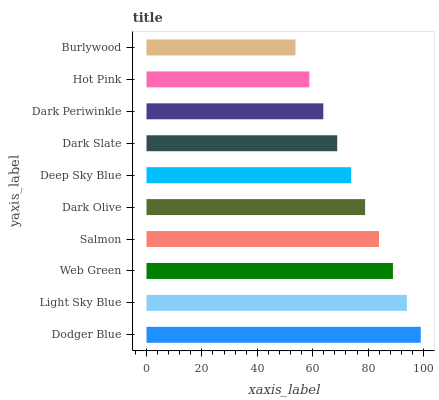Is Burlywood the minimum?
Answer yes or no. Yes. Is Dodger Blue the maximum?
Answer yes or no. Yes. Is Light Sky Blue the minimum?
Answer yes or no. No. Is Light Sky Blue the maximum?
Answer yes or no. No. Is Dodger Blue greater than Light Sky Blue?
Answer yes or no. Yes. Is Light Sky Blue less than Dodger Blue?
Answer yes or no. Yes. Is Light Sky Blue greater than Dodger Blue?
Answer yes or no. No. Is Dodger Blue less than Light Sky Blue?
Answer yes or no. No. Is Dark Olive the high median?
Answer yes or no. Yes. Is Deep Sky Blue the low median?
Answer yes or no. Yes. Is Dark Periwinkle the high median?
Answer yes or no. No. Is Dark Periwinkle the low median?
Answer yes or no. No. 